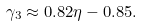<formula> <loc_0><loc_0><loc_500><loc_500>\gamma _ { 3 } \approx 0 . 8 2 \eta - 0 . 8 5 .</formula> 